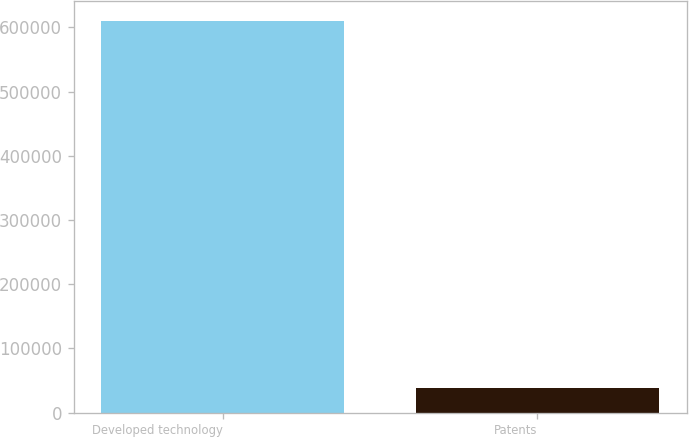Convert chart. <chart><loc_0><loc_0><loc_500><loc_500><bar_chart><fcel>Developed technology<fcel>Patents<nl><fcel>610512<fcel>38438<nl></chart> 